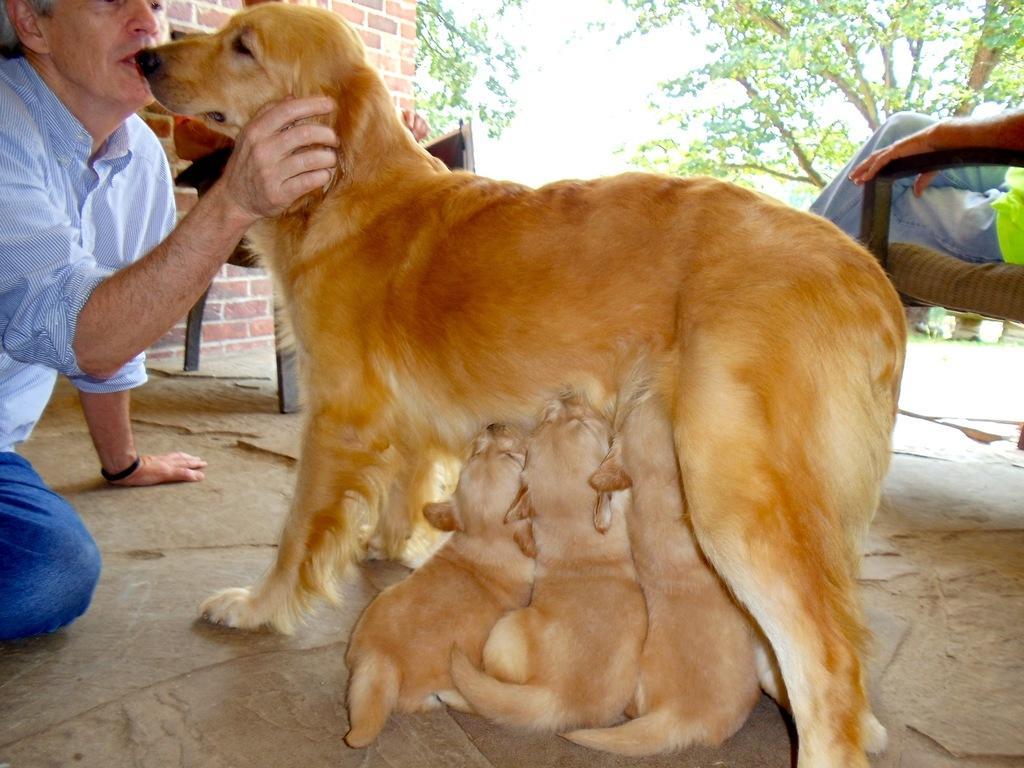In one or two sentences, can you explain what this image depicts? In this image we can see a person holding a dog, there are some puppies, also we can see a person sitting on a chair, there is a wall and trees, we can see the sky. 